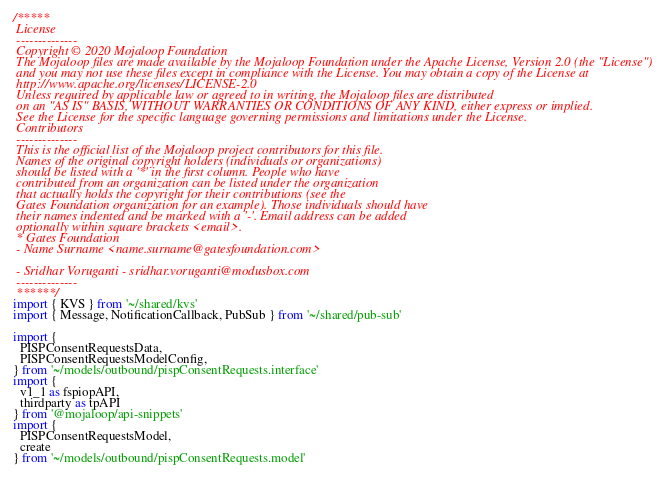<code> <loc_0><loc_0><loc_500><loc_500><_TypeScript_>/*****
 License
 --------------
 Copyright © 2020 Mojaloop Foundation
 The Mojaloop files are made available by the Mojaloop Foundation under the Apache License, Version 2.0 (the "License")
 and you may not use these files except in compliance with the License. You may obtain a copy of the License at
 http://www.apache.org/licenses/LICENSE-2.0
 Unless required by applicable law or agreed to in writing, the Mojaloop files are distributed
 on an "AS IS" BASIS, WITHOUT WARRANTIES OR CONDITIONS OF ANY KIND, either express or implied.
 See the License for the specific language governing permissions and limitations under the License.
 Contributors
 --------------
 This is the official list of the Mojaloop project contributors for this file.
 Names of the original copyright holders (individuals or organizations)
 should be listed with a '*' in the first column. People who have
 contributed from an organization can be listed under the organization
 that actually holds the copyright for their contributions (see the
 Gates Foundation organization for an example). Those individuals should have
 their names indented and be marked with a '-'. Email address can be added
 optionally within square brackets <email>.
 * Gates Foundation
 - Name Surname <name.surname@gatesfoundation.com>

 - Sridhar Voruganti - sridhar.voruganti@modusbox.com
 --------------
 ******/
import { KVS } from '~/shared/kvs'
import { Message, NotificationCallback, PubSub } from '~/shared/pub-sub'

import {
  PISPConsentRequestsData,
  PISPConsentRequestsModelConfig,
} from '~/models/outbound/pispConsentRequests.interface'
import {
  v1_1 as fspiopAPI,
  thirdparty as tpAPI
} from '@mojaloop/api-snippets'
import {
  PISPConsentRequestsModel,
  create
} from '~/models/outbound/pispConsentRequests.model'
</code> 